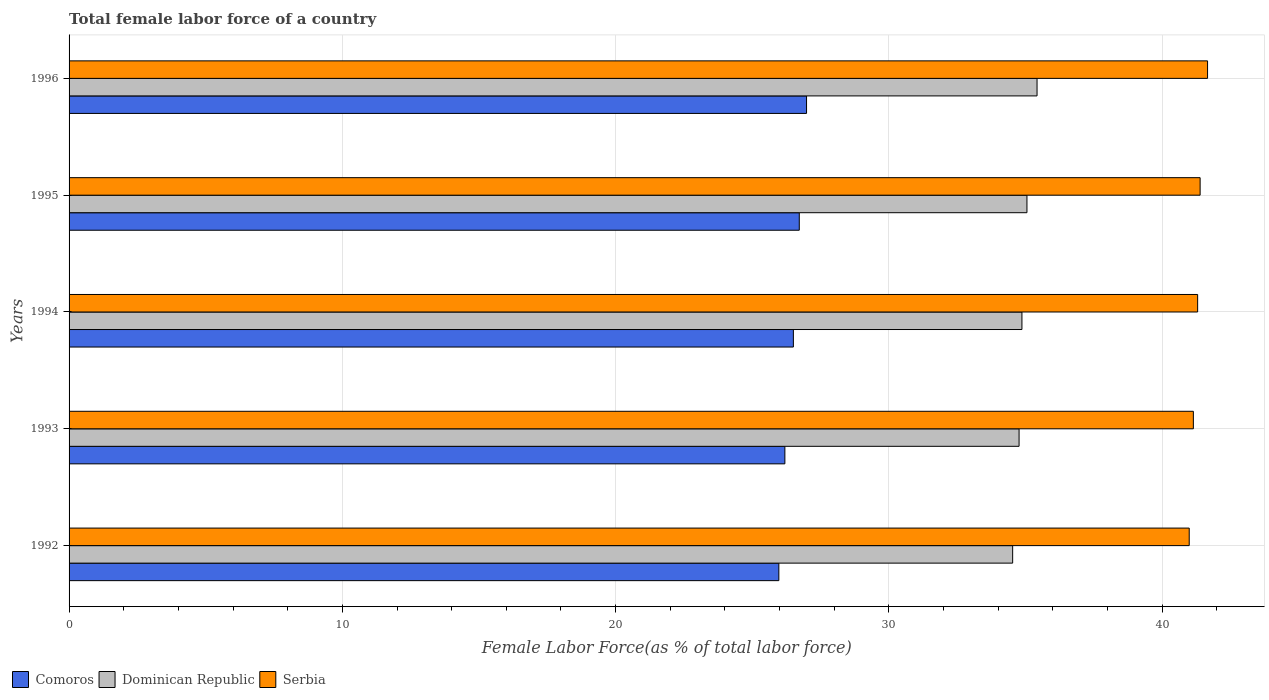How many different coloured bars are there?
Ensure brevity in your answer.  3. How many bars are there on the 2nd tick from the bottom?
Give a very brief answer. 3. In how many cases, is the number of bars for a given year not equal to the number of legend labels?
Offer a terse response. 0. What is the percentage of female labor force in Comoros in 1996?
Offer a terse response. 26.99. Across all years, what is the maximum percentage of female labor force in Serbia?
Provide a short and direct response. 41.66. Across all years, what is the minimum percentage of female labor force in Serbia?
Your response must be concise. 40.99. In which year was the percentage of female labor force in Comoros maximum?
Your answer should be compact. 1996. What is the total percentage of female labor force in Comoros in the graph?
Provide a succinct answer. 132.37. What is the difference between the percentage of female labor force in Serbia in 1994 and that in 1995?
Provide a short and direct response. -0.09. What is the difference between the percentage of female labor force in Comoros in 1992 and the percentage of female labor force in Dominican Republic in 1996?
Ensure brevity in your answer.  -9.45. What is the average percentage of female labor force in Dominican Republic per year?
Provide a short and direct response. 34.93. In the year 1996, what is the difference between the percentage of female labor force in Dominican Republic and percentage of female labor force in Serbia?
Make the answer very short. -6.24. What is the ratio of the percentage of female labor force in Comoros in 1993 to that in 1995?
Your answer should be compact. 0.98. Is the difference between the percentage of female labor force in Dominican Republic in 1992 and 1995 greater than the difference between the percentage of female labor force in Serbia in 1992 and 1995?
Ensure brevity in your answer.  No. What is the difference between the highest and the second highest percentage of female labor force in Comoros?
Give a very brief answer. 0.27. What is the difference between the highest and the lowest percentage of female labor force in Serbia?
Your response must be concise. 0.67. In how many years, is the percentage of female labor force in Comoros greater than the average percentage of female labor force in Comoros taken over all years?
Your answer should be very brief. 3. Is the sum of the percentage of female labor force in Dominican Republic in 1993 and 1995 greater than the maximum percentage of female labor force in Comoros across all years?
Your answer should be compact. Yes. What does the 1st bar from the top in 1995 represents?
Provide a short and direct response. Serbia. What does the 3rd bar from the bottom in 1995 represents?
Provide a short and direct response. Serbia. How many bars are there?
Offer a very short reply. 15. Are all the bars in the graph horizontal?
Your answer should be compact. Yes. How many years are there in the graph?
Your answer should be compact. 5. What is the difference between two consecutive major ticks on the X-axis?
Offer a very short reply. 10. Where does the legend appear in the graph?
Provide a short and direct response. Bottom left. What is the title of the graph?
Your response must be concise. Total female labor force of a country. Does "Australia" appear as one of the legend labels in the graph?
Keep it short and to the point. No. What is the label or title of the X-axis?
Keep it short and to the point. Female Labor Force(as % of total labor force). What is the label or title of the Y-axis?
Provide a short and direct response. Years. What is the Female Labor Force(as % of total labor force) in Comoros in 1992?
Make the answer very short. 25.97. What is the Female Labor Force(as % of total labor force) in Dominican Republic in 1992?
Your answer should be very brief. 34.53. What is the Female Labor Force(as % of total labor force) in Serbia in 1992?
Your answer should be very brief. 40.99. What is the Female Labor Force(as % of total labor force) of Comoros in 1993?
Keep it short and to the point. 26.19. What is the Female Labor Force(as % of total labor force) in Dominican Republic in 1993?
Give a very brief answer. 34.76. What is the Female Labor Force(as % of total labor force) of Serbia in 1993?
Give a very brief answer. 41.14. What is the Female Labor Force(as % of total labor force) in Comoros in 1994?
Provide a succinct answer. 26.5. What is the Female Labor Force(as % of total labor force) of Dominican Republic in 1994?
Your answer should be compact. 34.87. What is the Female Labor Force(as % of total labor force) of Serbia in 1994?
Your response must be concise. 41.3. What is the Female Labor Force(as % of total labor force) of Comoros in 1995?
Make the answer very short. 26.72. What is the Female Labor Force(as % of total labor force) of Dominican Republic in 1995?
Your answer should be very brief. 35.05. What is the Female Labor Force(as % of total labor force) of Serbia in 1995?
Your answer should be compact. 41.39. What is the Female Labor Force(as % of total labor force) of Comoros in 1996?
Provide a short and direct response. 26.99. What is the Female Labor Force(as % of total labor force) in Dominican Republic in 1996?
Offer a terse response. 35.42. What is the Female Labor Force(as % of total labor force) of Serbia in 1996?
Provide a short and direct response. 41.66. Across all years, what is the maximum Female Labor Force(as % of total labor force) of Comoros?
Provide a succinct answer. 26.99. Across all years, what is the maximum Female Labor Force(as % of total labor force) of Dominican Republic?
Make the answer very short. 35.42. Across all years, what is the maximum Female Labor Force(as % of total labor force) of Serbia?
Your answer should be very brief. 41.66. Across all years, what is the minimum Female Labor Force(as % of total labor force) in Comoros?
Keep it short and to the point. 25.97. Across all years, what is the minimum Female Labor Force(as % of total labor force) in Dominican Republic?
Offer a very short reply. 34.53. Across all years, what is the minimum Female Labor Force(as % of total labor force) of Serbia?
Provide a short and direct response. 40.99. What is the total Female Labor Force(as % of total labor force) of Comoros in the graph?
Provide a succinct answer. 132.37. What is the total Female Labor Force(as % of total labor force) in Dominican Republic in the graph?
Offer a very short reply. 174.63. What is the total Female Labor Force(as % of total labor force) in Serbia in the graph?
Provide a succinct answer. 206.47. What is the difference between the Female Labor Force(as % of total labor force) in Comoros in 1992 and that in 1993?
Offer a very short reply. -0.22. What is the difference between the Female Labor Force(as % of total labor force) of Dominican Republic in 1992 and that in 1993?
Offer a terse response. -0.23. What is the difference between the Female Labor Force(as % of total labor force) of Serbia in 1992 and that in 1993?
Your answer should be compact. -0.15. What is the difference between the Female Labor Force(as % of total labor force) of Comoros in 1992 and that in 1994?
Provide a succinct answer. -0.53. What is the difference between the Female Labor Force(as % of total labor force) of Dominican Republic in 1992 and that in 1994?
Keep it short and to the point. -0.34. What is the difference between the Female Labor Force(as % of total labor force) in Serbia in 1992 and that in 1994?
Make the answer very short. -0.31. What is the difference between the Female Labor Force(as % of total labor force) in Comoros in 1992 and that in 1995?
Provide a short and direct response. -0.75. What is the difference between the Female Labor Force(as % of total labor force) of Dominican Republic in 1992 and that in 1995?
Make the answer very short. -0.52. What is the difference between the Female Labor Force(as % of total labor force) of Serbia in 1992 and that in 1995?
Your answer should be very brief. -0.4. What is the difference between the Female Labor Force(as % of total labor force) in Comoros in 1992 and that in 1996?
Offer a very short reply. -1.01. What is the difference between the Female Labor Force(as % of total labor force) in Dominican Republic in 1992 and that in 1996?
Your answer should be compact. -0.89. What is the difference between the Female Labor Force(as % of total labor force) of Serbia in 1992 and that in 1996?
Offer a terse response. -0.67. What is the difference between the Female Labor Force(as % of total labor force) of Comoros in 1993 and that in 1994?
Your answer should be very brief. -0.31. What is the difference between the Female Labor Force(as % of total labor force) in Dominican Republic in 1993 and that in 1994?
Your answer should be compact. -0.1. What is the difference between the Female Labor Force(as % of total labor force) in Serbia in 1993 and that in 1994?
Offer a very short reply. -0.16. What is the difference between the Female Labor Force(as % of total labor force) in Comoros in 1993 and that in 1995?
Provide a succinct answer. -0.53. What is the difference between the Female Labor Force(as % of total labor force) of Dominican Republic in 1993 and that in 1995?
Your answer should be compact. -0.29. What is the difference between the Female Labor Force(as % of total labor force) of Serbia in 1993 and that in 1995?
Your response must be concise. -0.25. What is the difference between the Female Labor Force(as % of total labor force) of Comoros in 1993 and that in 1996?
Offer a terse response. -0.79. What is the difference between the Female Labor Force(as % of total labor force) of Dominican Republic in 1993 and that in 1996?
Give a very brief answer. -0.66. What is the difference between the Female Labor Force(as % of total labor force) in Serbia in 1993 and that in 1996?
Your response must be concise. -0.52. What is the difference between the Female Labor Force(as % of total labor force) in Comoros in 1994 and that in 1995?
Keep it short and to the point. -0.22. What is the difference between the Female Labor Force(as % of total labor force) in Dominican Republic in 1994 and that in 1995?
Provide a succinct answer. -0.18. What is the difference between the Female Labor Force(as % of total labor force) in Serbia in 1994 and that in 1995?
Give a very brief answer. -0.09. What is the difference between the Female Labor Force(as % of total labor force) in Comoros in 1994 and that in 1996?
Make the answer very short. -0.48. What is the difference between the Female Labor Force(as % of total labor force) in Dominican Republic in 1994 and that in 1996?
Offer a terse response. -0.55. What is the difference between the Female Labor Force(as % of total labor force) in Serbia in 1994 and that in 1996?
Make the answer very short. -0.36. What is the difference between the Female Labor Force(as % of total labor force) in Comoros in 1995 and that in 1996?
Keep it short and to the point. -0.27. What is the difference between the Female Labor Force(as % of total labor force) in Dominican Republic in 1995 and that in 1996?
Your answer should be very brief. -0.37. What is the difference between the Female Labor Force(as % of total labor force) of Serbia in 1995 and that in 1996?
Provide a short and direct response. -0.27. What is the difference between the Female Labor Force(as % of total labor force) of Comoros in 1992 and the Female Labor Force(as % of total labor force) of Dominican Republic in 1993?
Offer a very short reply. -8.79. What is the difference between the Female Labor Force(as % of total labor force) in Comoros in 1992 and the Female Labor Force(as % of total labor force) in Serbia in 1993?
Provide a short and direct response. -15.17. What is the difference between the Female Labor Force(as % of total labor force) in Dominican Republic in 1992 and the Female Labor Force(as % of total labor force) in Serbia in 1993?
Your response must be concise. -6.61. What is the difference between the Female Labor Force(as % of total labor force) of Comoros in 1992 and the Female Labor Force(as % of total labor force) of Dominican Republic in 1994?
Provide a short and direct response. -8.89. What is the difference between the Female Labor Force(as % of total labor force) of Comoros in 1992 and the Female Labor Force(as % of total labor force) of Serbia in 1994?
Your answer should be very brief. -15.32. What is the difference between the Female Labor Force(as % of total labor force) of Dominican Republic in 1992 and the Female Labor Force(as % of total labor force) of Serbia in 1994?
Provide a short and direct response. -6.77. What is the difference between the Female Labor Force(as % of total labor force) in Comoros in 1992 and the Female Labor Force(as % of total labor force) in Dominican Republic in 1995?
Provide a succinct answer. -9.08. What is the difference between the Female Labor Force(as % of total labor force) of Comoros in 1992 and the Female Labor Force(as % of total labor force) of Serbia in 1995?
Ensure brevity in your answer.  -15.42. What is the difference between the Female Labor Force(as % of total labor force) in Dominican Republic in 1992 and the Female Labor Force(as % of total labor force) in Serbia in 1995?
Give a very brief answer. -6.86. What is the difference between the Female Labor Force(as % of total labor force) of Comoros in 1992 and the Female Labor Force(as % of total labor force) of Dominican Republic in 1996?
Provide a succinct answer. -9.45. What is the difference between the Female Labor Force(as % of total labor force) in Comoros in 1992 and the Female Labor Force(as % of total labor force) in Serbia in 1996?
Offer a very short reply. -15.69. What is the difference between the Female Labor Force(as % of total labor force) of Dominican Republic in 1992 and the Female Labor Force(as % of total labor force) of Serbia in 1996?
Make the answer very short. -7.13. What is the difference between the Female Labor Force(as % of total labor force) in Comoros in 1993 and the Female Labor Force(as % of total labor force) in Dominican Republic in 1994?
Your response must be concise. -8.67. What is the difference between the Female Labor Force(as % of total labor force) in Comoros in 1993 and the Female Labor Force(as % of total labor force) in Serbia in 1994?
Offer a very short reply. -15.1. What is the difference between the Female Labor Force(as % of total labor force) in Dominican Republic in 1993 and the Female Labor Force(as % of total labor force) in Serbia in 1994?
Your answer should be very brief. -6.53. What is the difference between the Female Labor Force(as % of total labor force) in Comoros in 1993 and the Female Labor Force(as % of total labor force) in Dominican Republic in 1995?
Give a very brief answer. -8.86. What is the difference between the Female Labor Force(as % of total labor force) of Comoros in 1993 and the Female Labor Force(as % of total labor force) of Serbia in 1995?
Provide a succinct answer. -15.19. What is the difference between the Female Labor Force(as % of total labor force) of Dominican Republic in 1993 and the Female Labor Force(as % of total labor force) of Serbia in 1995?
Give a very brief answer. -6.63. What is the difference between the Female Labor Force(as % of total labor force) in Comoros in 1993 and the Female Labor Force(as % of total labor force) in Dominican Republic in 1996?
Make the answer very short. -9.23. What is the difference between the Female Labor Force(as % of total labor force) in Comoros in 1993 and the Female Labor Force(as % of total labor force) in Serbia in 1996?
Your answer should be compact. -15.47. What is the difference between the Female Labor Force(as % of total labor force) of Dominican Republic in 1993 and the Female Labor Force(as % of total labor force) of Serbia in 1996?
Provide a short and direct response. -6.9. What is the difference between the Female Labor Force(as % of total labor force) of Comoros in 1994 and the Female Labor Force(as % of total labor force) of Dominican Republic in 1995?
Your answer should be very brief. -8.55. What is the difference between the Female Labor Force(as % of total labor force) of Comoros in 1994 and the Female Labor Force(as % of total labor force) of Serbia in 1995?
Your answer should be very brief. -14.88. What is the difference between the Female Labor Force(as % of total labor force) in Dominican Republic in 1994 and the Female Labor Force(as % of total labor force) in Serbia in 1995?
Provide a short and direct response. -6.52. What is the difference between the Female Labor Force(as % of total labor force) of Comoros in 1994 and the Female Labor Force(as % of total labor force) of Dominican Republic in 1996?
Provide a succinct answer. -8.92. What is the difference between the Female Labor Force(as % of total labor force) of Comoros in 1994 and the Female Labor Force(as % of total labor force) of Serbia in 1996?
Give a very brief answer. -15.16. What is the difference between the Female Labor Force(as % of total labor force) of Dominican Republic in 1994 and the Female Labor Force(as % of total labor force) of Serbia in 1996?
Offer a very short reply. -6.79. What is the difference between the Female Labor Force(as % of total labor force) in Comoros in 1995 and the Female Labor Force(as % of total labor force) in Dominican Republic in 1996?
Offer a very short reply. -8.7. What is the difference between the Female Labor Force(as % of total labor force) in Comoros in 1995 and the Female Labor Force(as % of total labor force) in Serbia in 1996?
Offer a terse response. -14.94. What is the difference between the Female Labor Force(as % of total labor force) in Dominican Republic in 1995 and the Female Labor Force(as % of total labor force) in Serbia in 1996?
Make the answer very short. -6.61. What is the average Female Labor Force(as % of total labor force) of Comoros per year?
Your answer should be very brief. 26.47. What is the average Female Labor Force(as % of total labor force) of Dominican Republic per year?
Your answer should be very brief. 34.93. What is the average Female Labor Force(as % of total labor force) in Serbia per year?
Provide a short and direct response. 41.29. In the year 1992, what is the difference between the Female Labor Force(as % of total labor force) of Comoros and Female Labor Force(as % of total labor force) of Dominican Republic?
Your response must be concise. -8.56. In the year 1992, what is the difference between the Female Labor Force(as % of total labor force) of Comoros and Female Labor Force(as % of total labor force) of Serbia?
Provide a succinct answer. -15.02. In the year 1992, what is the difference between the Female Labor Force(as % of total labor force) of Dominican Republic and Female Labor Force(as % of total labor force) of Serbia?
Make the answer very short. -6.46. In the year 1993, what is the difference between the Female Labor Force(as % of total labor force) in Comoros and Female Labor Force(as % of total labor force) in Dominican Republic?
Your answer should be very brief. -8.57. In the year 1993, what is the difference between the Female Labor Force(as % of total labor force) of Comoros and Female Labor Force(as % of total labor force) of Serbia?
Keep it short and to the point. -14.95. In the year 1993, what is the difference between the Female Labor Force(as % of total labor force) in Dominican Republic and Female Labor Force(as % of total labor force) in Serbia?
Ensure brevity in your answer.  -6.38. In the year 1994, what is the difference between the Female Labor Force(as % of total labor force) in Comoros and Female Labor Force(as % of total labor force) in Dominican Republic?
Offer a very short reply. -8.36. In the year 1994, what is the difference between the Female Labor Force(as % of total labor force) in Comoros and Female Labor Force(as % of total labor force) in Serbia?
Provide a short and direct response. -14.79. In the year 1994, what is the difference between the Female Labor Force(as % of total labor force) of Dominican Republic and Female Labor Force(as % of total labor force) of Serbia?
Your response must be concise. -6.43. In the year 1995, what is the difference between the Female Labor Force(as % of total labor force) in Comoros and Female Labor Force(as % of total labor force) in Dominican Republic?
Your answer should be very brief. -8.33. In the year 1995, what is the difference between the Female Labor Force(as % of total labor force) of Comoros and Female Labor Force(as % of total labor force) of Serbia?
Offer a terse response. -14.67. In the year 1995, what is the difference between the Female Labor Force(as % of total labor force) of Dominican Republic and Female Labor Force(as % of total labor force) of Serbia?
Your answer should be very brief. -6.34. In the year 1996, what is the difference between the Female Labor Force(as % of total labor force) of Comoros and Female Labor Force(as % of total labor force) of Dominican Republic?
Your answer should be compact. -8.43. In the year 1996, what is the difference between the Female Labor Force(as % of total labor force) in Comoros and Female Labor Force(as % of total labor force) in Serbia?
Offer a terse response. -14.67. In the year 1996, what is the difference between the Female Labor Force(as % of total labor force) of Dominican Republic and Female Labor Force(as % of total labor force) of Serbia?
Your answer should be very brief. -6.24. What is the ratio of the Female Labor Force(as % of total labor force) in Dominican Republic in 1992 to that in 1993?
Offer a terse response. 0.99. What is the ratio of the Female Labor Force(as % of total labor force) in Serbia in 1992 to that in 1993?
Provide a succinct answer. 1. What is the ratio of the Female Labor Force(as % of total labor force) of Comoros in 1992 to that in 1994?
Provide a short and direct response. 0.98. What is the ratio of the Female Labor Force(as % of total labor force) of Dominican Republic in 1992 to that in 1994?
Make the answer very short. 0.99. What is the ratio of the Female Labor Force(as % of total labor force) in Serbia in 1992 to that in 1994?
Your answer should be very brief. 0.99. What is the ratio of the Female Labor Force(as % of total labor force) of Comoros in 1992 to that in 1995?
Your answer should be compact. 0.97. What is the ratio of the Female Labor Force(as % of total labor force) of Dominican Republic in 1992 to that in 1995?
Provide a succinct answer. 0.99. What is the ratio of the Female Labor Force(as % of total labor force) in Serbia in 1992 to that in 1995?
Your response must be concise. 0.99. What is the ratio of the Female Labor Force(as % of total labor force) of Comoros in 1992 to that in 1996?
Offer a terse response. 0.96. What is the ratio of the Female Labor Force(as % of total labor force) of Dominican Republic in 1992 to that in 1996?
Your response must be concise. 0.97. What is the ratio of the Female Labor Force(as % of total labor force) in Serbia in 1992 to that in 1996?
Keep it short and to the point. 0.98. What is the ratio of the Female Labor Force(as % of total labor force) in Comoros in 1993 to that in 1994?
Provide a short and direct response. 0.99. What is the ratio of the Female Labor Force(as % of total labor force) of Dominican Republic in 1993 to that in 1994?
Provide a succinct answer. 1. What is the ratio of the Female Labor Force(as % of total labor force) in Comoros in 1993 to that in 1995?
Your response must be concise. 0.98. What is the ratio of the Female Labor Force(as % of total labor force) in Dominican Republic in 1993 to that in 1995?
Provide a short and direct response. 0.99. What is the ratio of the Female Labor Force(as % of total labor force) in Serbia in 1993 to that in 1995?
Offer a very short reply. 0.99. What is the ratio of the Female Labor Force(as % of total labor force) of Comoros in 1993 to that in 1996?
Give a very brief answer. 0.97. What is the ratio of the Female Labor Force(as % of total labor force) in Dominican Republic in 1993 to that in 1996?
Give a very brief answer. 0.98. What is the ratio of the Female Labor Force(as % of total labor force) of Serbia in 1993 to that in 1996?
Your answer should be very brief. 0.99. What is the ratio of the Female Labor Force(as % of total labor force) in Comoros in 1994 to that in 1995?
Offer a terse response. 0.99. What is the ratio of the Female Labor Force(as % of total labor force) in Comoros in 1994 to that in 1996?
Your answer should be very brief. 0.98. What is the ratio of the Female Labor Force(as % of total labor force) of Dominican Republic in 1994 to that in 1996?
Provide a short and direct response. 0.98. What is the ratio of the Female Labor Force(as % of total labor force) in Comoros in 1995 to that in 1996?
Your response must be concise. 0.99. What is the difference between the highest and the second highest Female Labor Force(as % of total labor force) in Comoros?
Keep it short and to the point. 0.27. What is the difference between the highest and the second highest Female Labor Force(as % of total labor force) in Dominican Republic?
Offer a very short reply. 0.37. What is the difference between the highest and the second highest Female Labor Force(as % of total labor force) of Serbia?
Your answer should be very brief. 0.27. What is the difference between the highest and the lowest Female Labor Force(as % of total labor force) of Comoros?
Ensure brevity in your answer.  1.01. What is the difference between the highest and the lowest Female Labor Force(as % of total labor force) of Dominican Republic?
Provide a succinct answer. 0.89. What is the difference between the highest and the lowest Female Labor Force(as % of total labor force) in Serbia?
Your answer should be compact. 0.67. 